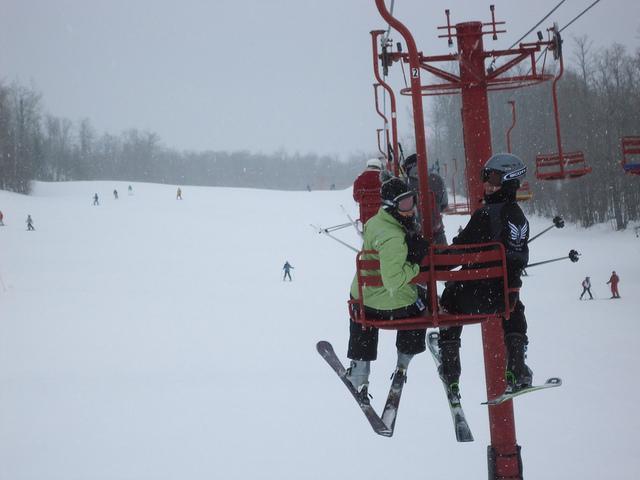How many are on the ski lift?
Give a very brief answer. 4. How many people are on the ski lift?
Give a very brief answer. 4. How many people are visible?
Give a very brief answer. 2. How many buses are there?
Give a very brief answer. 0. 